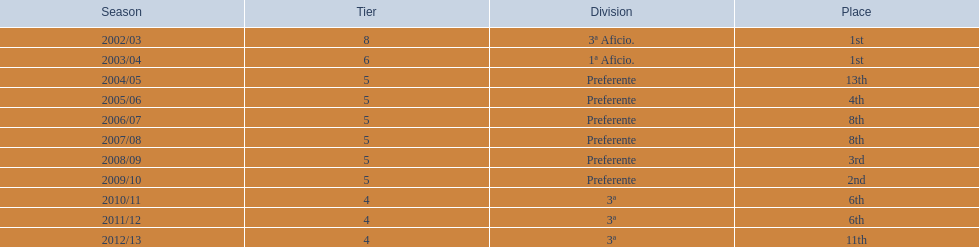What seasons transpired in tier four? 2010/11, 2011/12, 2012/13. Of these seasons, which ended in 6th spot? 2010/11, 2011/12. Which of the remaining ones happened last? 2011/12. 